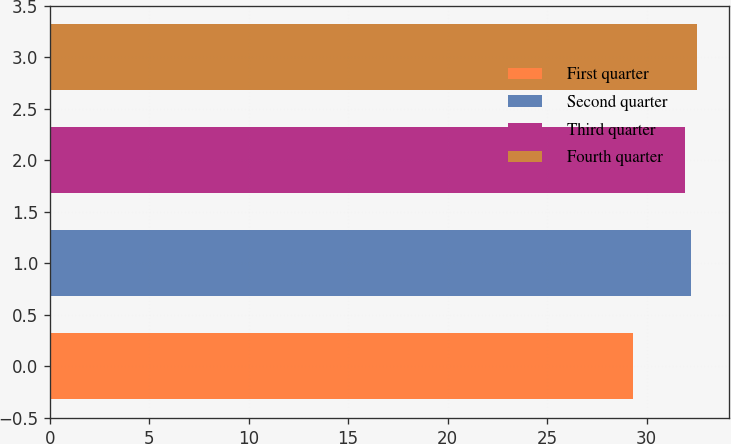Convert chart to OTSL. <chart><loc_0><loc_0><loc_500><loc_500><bar_chart><fcel>First quarter<fcel>Second quarter<fcel>Third quarter<fcel>Fourth quarter<nl><fcel>29.34<fcel>32.23<fcel>31.94<fcel>32.52<nl></chart> 